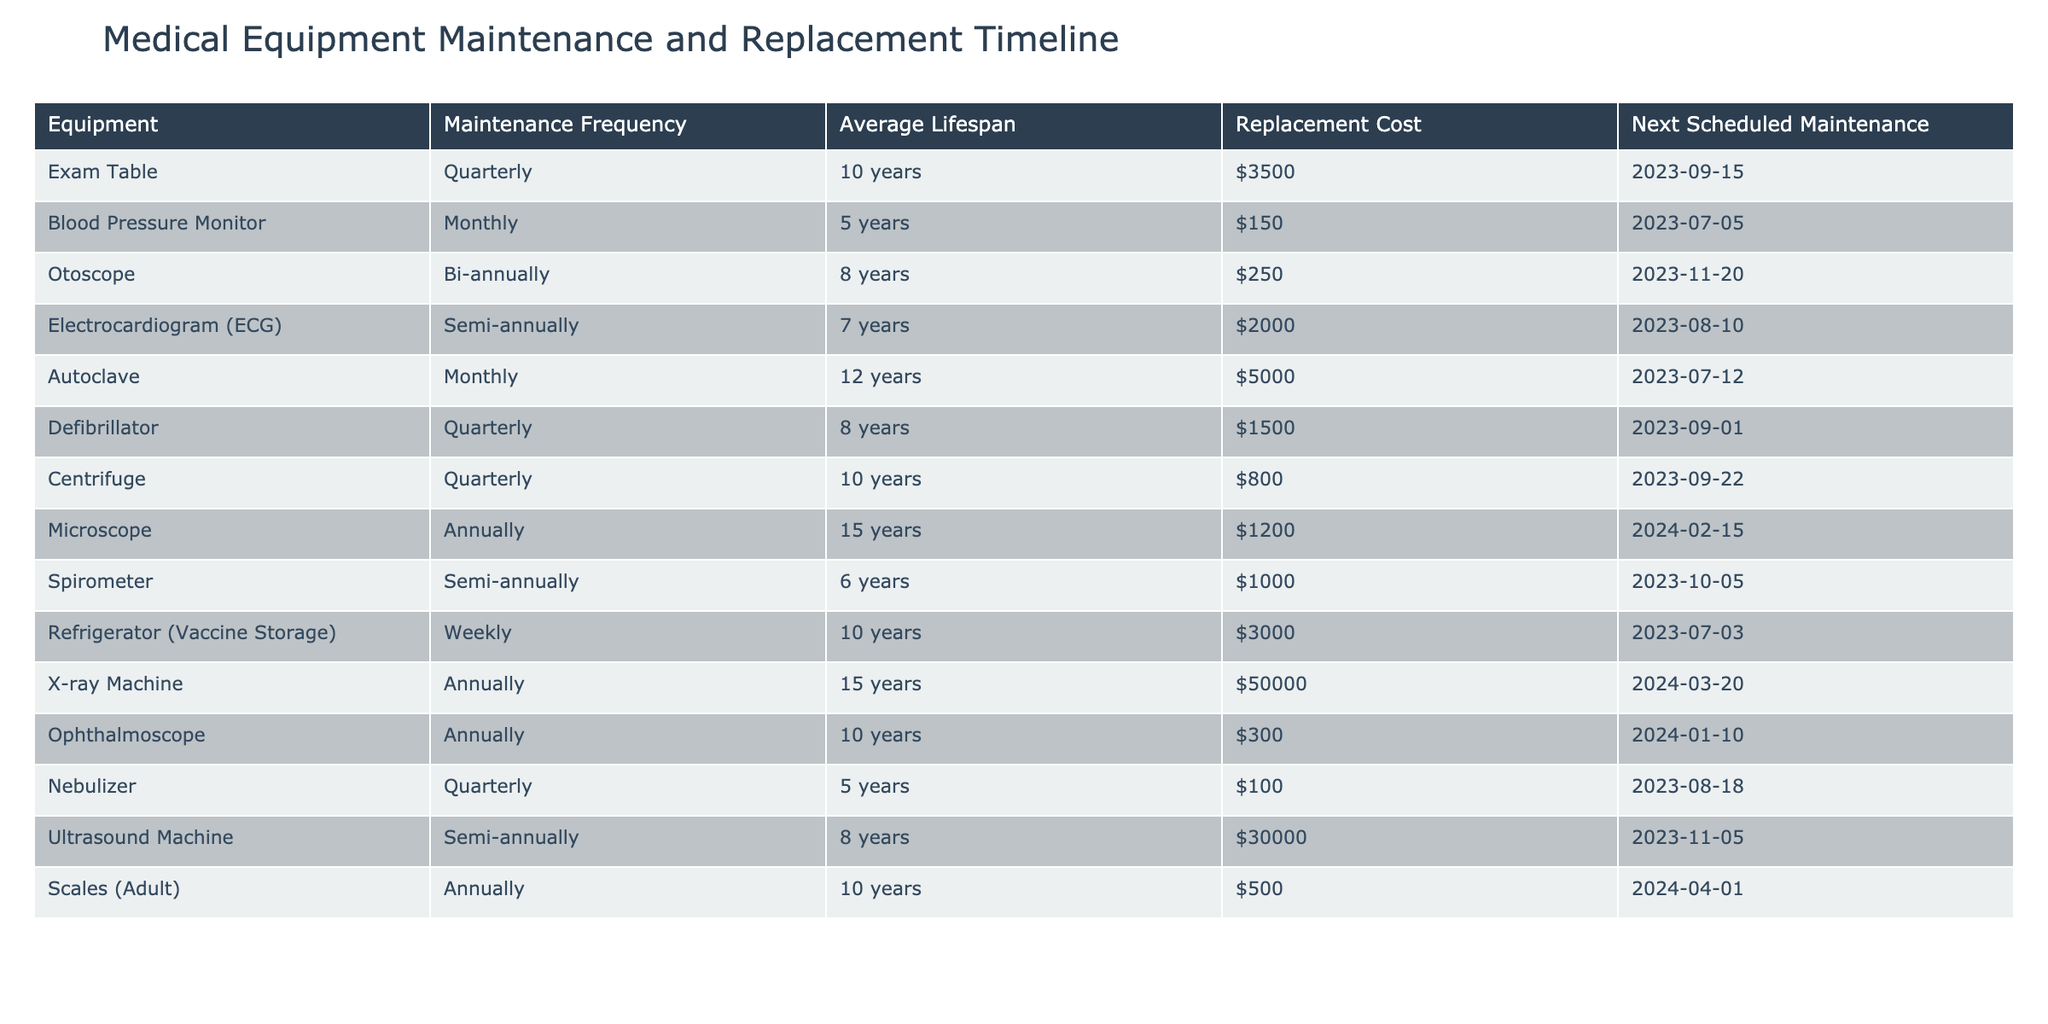What is the next scheduled maintenance date for the Blood Pressure Monitor? The next scheduled maintenance date is listed in the table under the "Next Scheduled Maintenance" column for the Blood Pressure Monitor, which shows "2023-07-05."
Answer: 2023-07-05 How often is the Ultrasound Machine maintained? The maintenance frequency for the Ultrasound Machine is provided in the "Maintenance Frequency" column, which states that it is maintained semi-annually.
Answer: Semi-annually What is the average lifespan of the Nebulizer? The average lifespan of the Nebulizer is located in the "Average Lifespan" column of the table, which indicates 5 years.
Answer: 5 years How much does it cost to replace the X-ray Machine? The replacement cost for the X-ray Machine can be found in the "Replacement Cost" column, which states $50,000.
Answer: $50,000 What is the sum of the average lifespan of the Exam Table and the Centrifuge? The average lifespan of the Exam Table is 10 years, and the Centrifuge is also 10 years, so the sum is 10 + 10 = 20 years.
Answer: 20 years Is the next scheduled maintenance for the Autoclave due before the next maintenance of the Blood Pressure Monitor? The next scheduled maintenance for the Autoclave is on 2023-07-12, and for the Blood Pressure Monitor, it is on 2023-07-05. Since 2023-07-12 is after 2023-07-05, the Autoclave is due after the Blood Pressure Monitor.
Answer: No How many pieces of equipment require maintenance quarterly? From the table, the pieces of equipment that require quarterly maintenance are the Exam Table, Defibrillator, Centrifuge, and Nebulizer. Counting these, there are 4 pieces of equipment.
Answer: 4 What is the difference in replacement cost between the Ultrasound Machine and the Electrocardiogram (ECG)? The replacement cost for the Ultrasound Machine is $30,000 and for the ECG is $2,000. The difference is $30,000 - $2,000 = $28,000.
Answer: $28,000 Which equipment has the least average lifespan? The equipment with the least average lifespan is the Nebulizer, which has an average lifespan of 5 years as indicated in the "Average Lifespan" column.
Answer: Nebulizer Which equipment requires maintenance the most frequently? The equipment that requires maintenance the most frequently is the Refrigerator (Vaccine Storage), which needs maintenance weekly as shown in the "Maintenance Frequency" column.
Answer: Refrigerator (Vaccine Storage) 